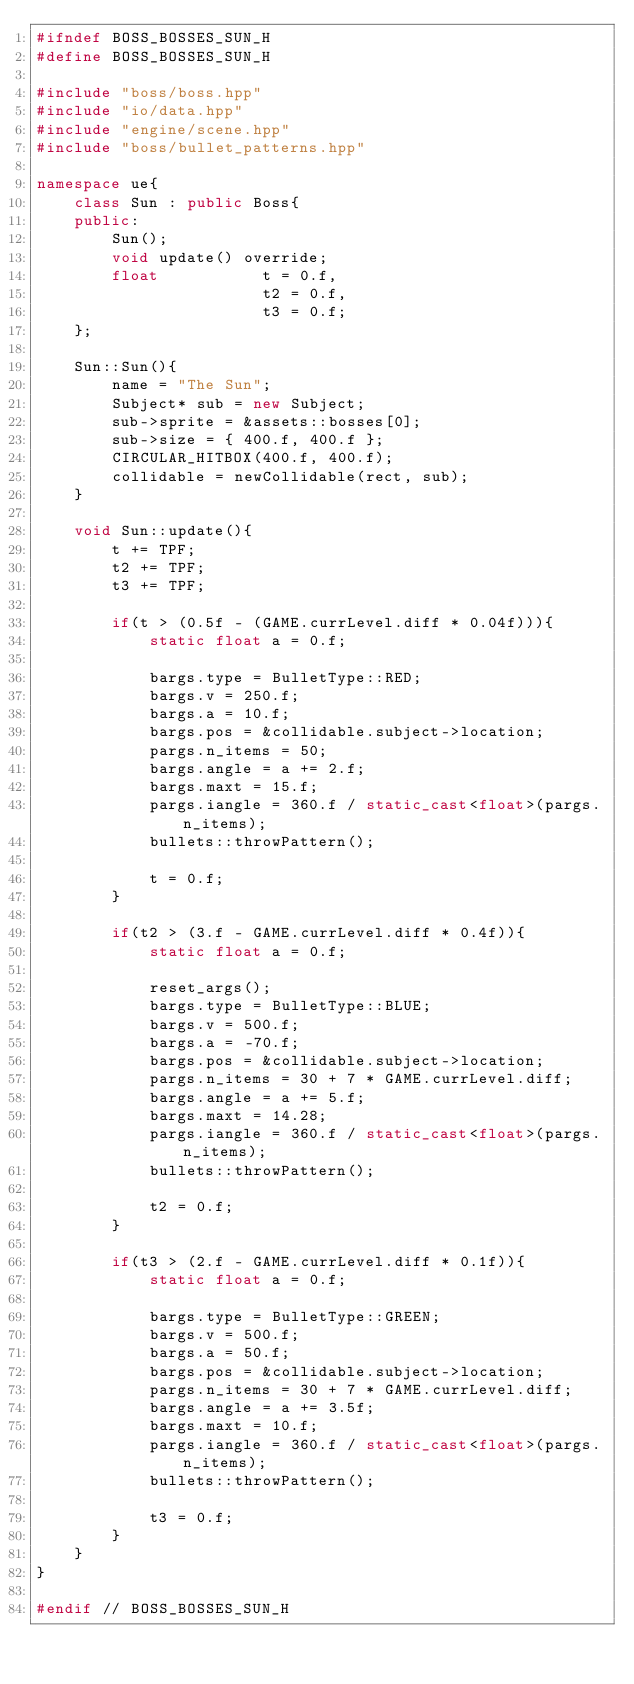<code> <loc_0><loc_0><loc_500><loc_500><_C++_>#ifndef BOSS_BOSSES_SUN_H
#define BOSS_BOSSES_SUN_H

#include "boss/boss.hpp"
#include "io/data.hpp"
#include "engine/scene.hpp"
#include "boss/bullet_patterns.hpp"

namespace ue{
    class Sun : public Boss{
    public:
        Sun();
        void update() override;
        float           t = 0.f,
                        t2 = 0.f,
                        t3 = 0.f;
    };

    Sun::Sun(){
        name = "The Sun";
        Subject* sub = new Subject;
        sub->sprite = &assets::bosses[0];
        sub->size = { 400.f, 400.f };
        CIRCULAR_HITBOX(400.f, 400.f);
        collidable = newCollidable(rect, sub);
    }

    void Sun::update(){
        t += TPF;
        t2 += TPF;
        t3 += TPF;

        if(t > (0.5f - (GAME.currLevel.diff * 0.04f))){
            static float a = 0.f;

            bargs.type = BulletType::RED;
            bargs.v = 250.f;
            bargs.a = 10.f;
            bargs.pos = &collidable.subject->location;
            pargs.n_items = 50;
            bargs.angle = a += 2.f;
            bargs.maxt = 15.f;
            pargs.iangle = 360.f / static_cast<float>(pargs.n_items);
            bullets::throwPattern();

            t = 0.f;
        }

        if(t2 > (3.f - GAME.currLevel.diff * 0.4f)){
            static float a = 0.f;

            reset_args();
            bargs.type = BulletType::BLUE;
            bargs.v = 500.f;
            bargs.a = -70.f;
            bargs.pos = &collidable.subject->location;
            pargs.n_items = 30 + 7 * GAME.currLevel.diff;
            bargs.angle = a += 5.f;
            bargs.maxt = 14.28;
            pargs.iangle = 360.f / static_cast<float>(pargs.n_items);
            bullets::throwPattern();

            t2 = 0.f;
        }

        if(t3 > (2.f - GAME.currLevel.diff * 0.1f)){
            static float a = 0.f;

            bargs.type = BulletType::GREEN;
            bargs.v = 500.f;
            bargs.a = 50.f;
            bargs.pos = &collidable.subject->location;
            pargs.n_items = 30 + 7 * GAME.currLevel.diff;
            bargs.angle = a += 3.5f;
            bargs.maxt = 10.f;
            pargs.iangle = 360.f / static_cast<float>(pargs.n_items);
            bullets::throwPattern();

            t3 = 0.f;
        }
    }
}

#endif // BOSS_BOSSES_SUN_H
</code> 